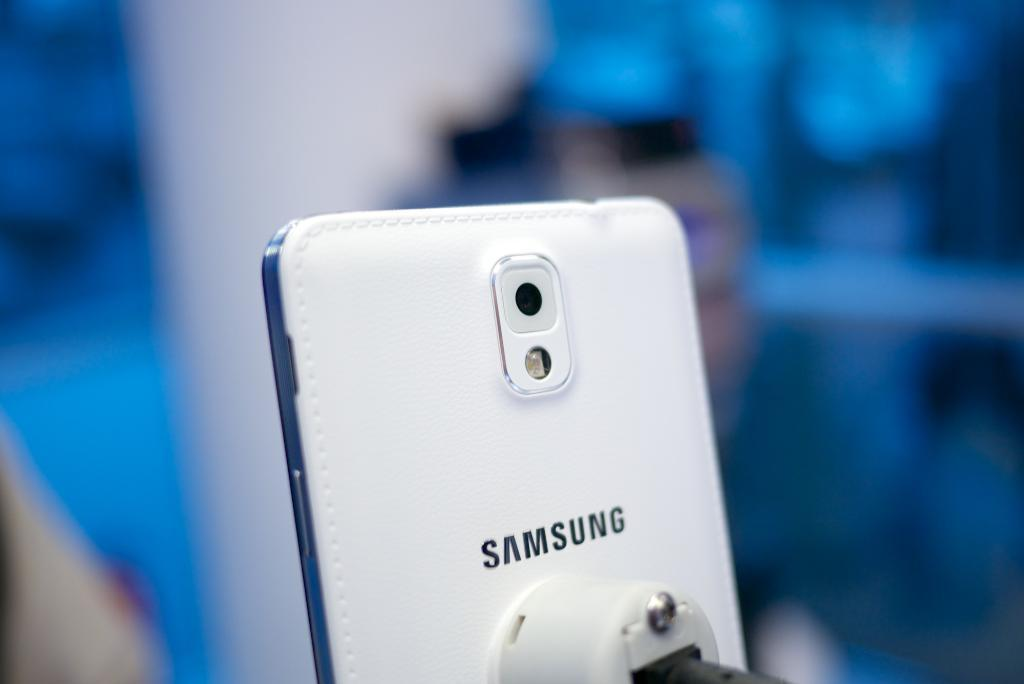<image>
Provide a brief description of the given image. The back of a Samsung phone features a stitched white leather cover. 